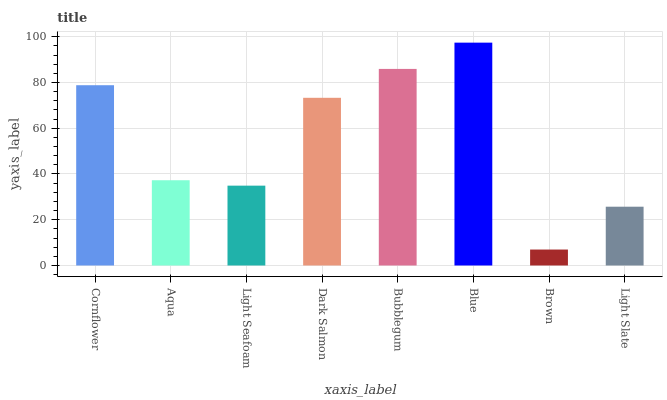Is Brown the minimum?
Answer yes or no. Yes. Is Blue the maximum?
Answer yes or no. Yes. Is Aqua the minimum?
Answer yes or no. No. Is Aqua the maximum?
Answer yes or no. No. Is Cornflower greater than Aqua?
Answer yes or no. Yes. Is Aqua less than Cornflower?
Answer yes or no. Yes. Is Aqua greater than Cornflower?
Answer yes or no. No. Is Cornflower less than Aqua?
Answer yes or no. No. Is Dark Salmon the high median?
Answer yes or no. Yes. Is Aqua the low median?
Answer yes or no. Yes. Is Cornflower the high median?
Answer yes or no. No. Is Bubblegum the low median?
Answer yes or no. No. 